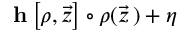Convert formula to latex. <formula><loc_0><loc_0><loc_500><loc_500>h \left [ \rho , \vec { z } \right ] \circ \rho ( \vec { z } \, ) + \eta</formula> 